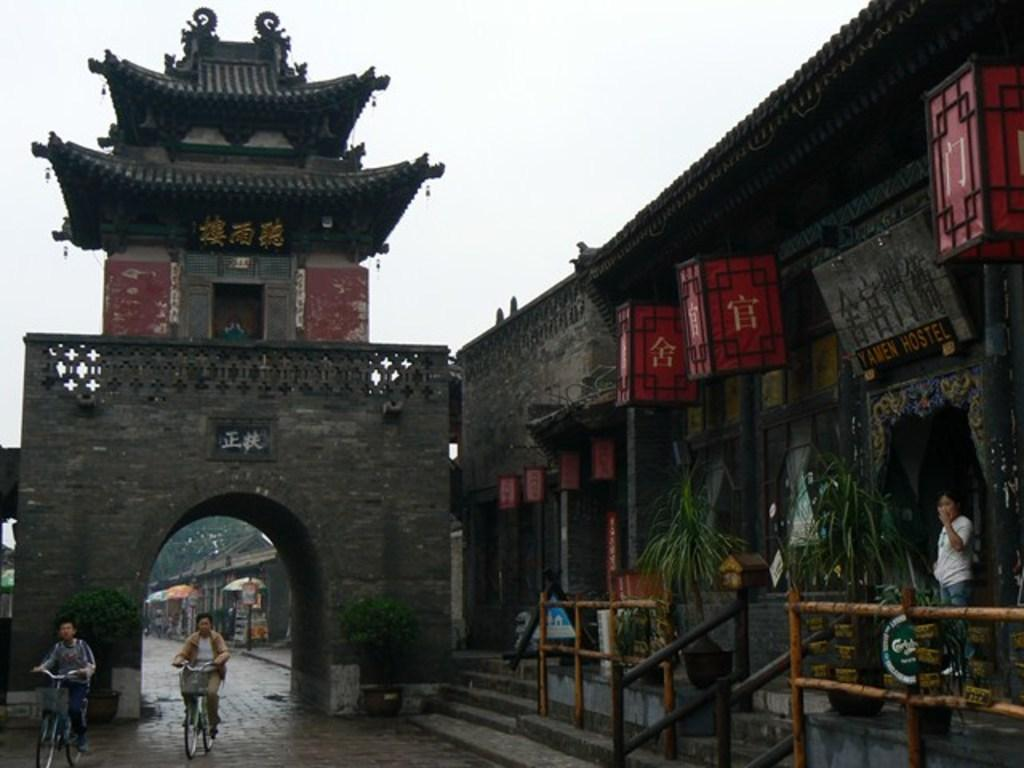What type of structure is present in the image? There is an arch in the image. What can be seen on the right side of the image? There is a building on the right side of the image. What are the two persons on the left side of the image doing? The two persons are riding bicycles on the left side of the image. What is visible at the top of the image? The sky is visible at the top of the image. What is the condition of the sky in the image? The sky is cloudy in the image. How much money is being exchanged between the two persons riding bicycles in the image? There is no indication of any money exchange in the image; the two persons are simply riding bicycles. What type of bone can be seen in the image? There is no bone present in the image. 